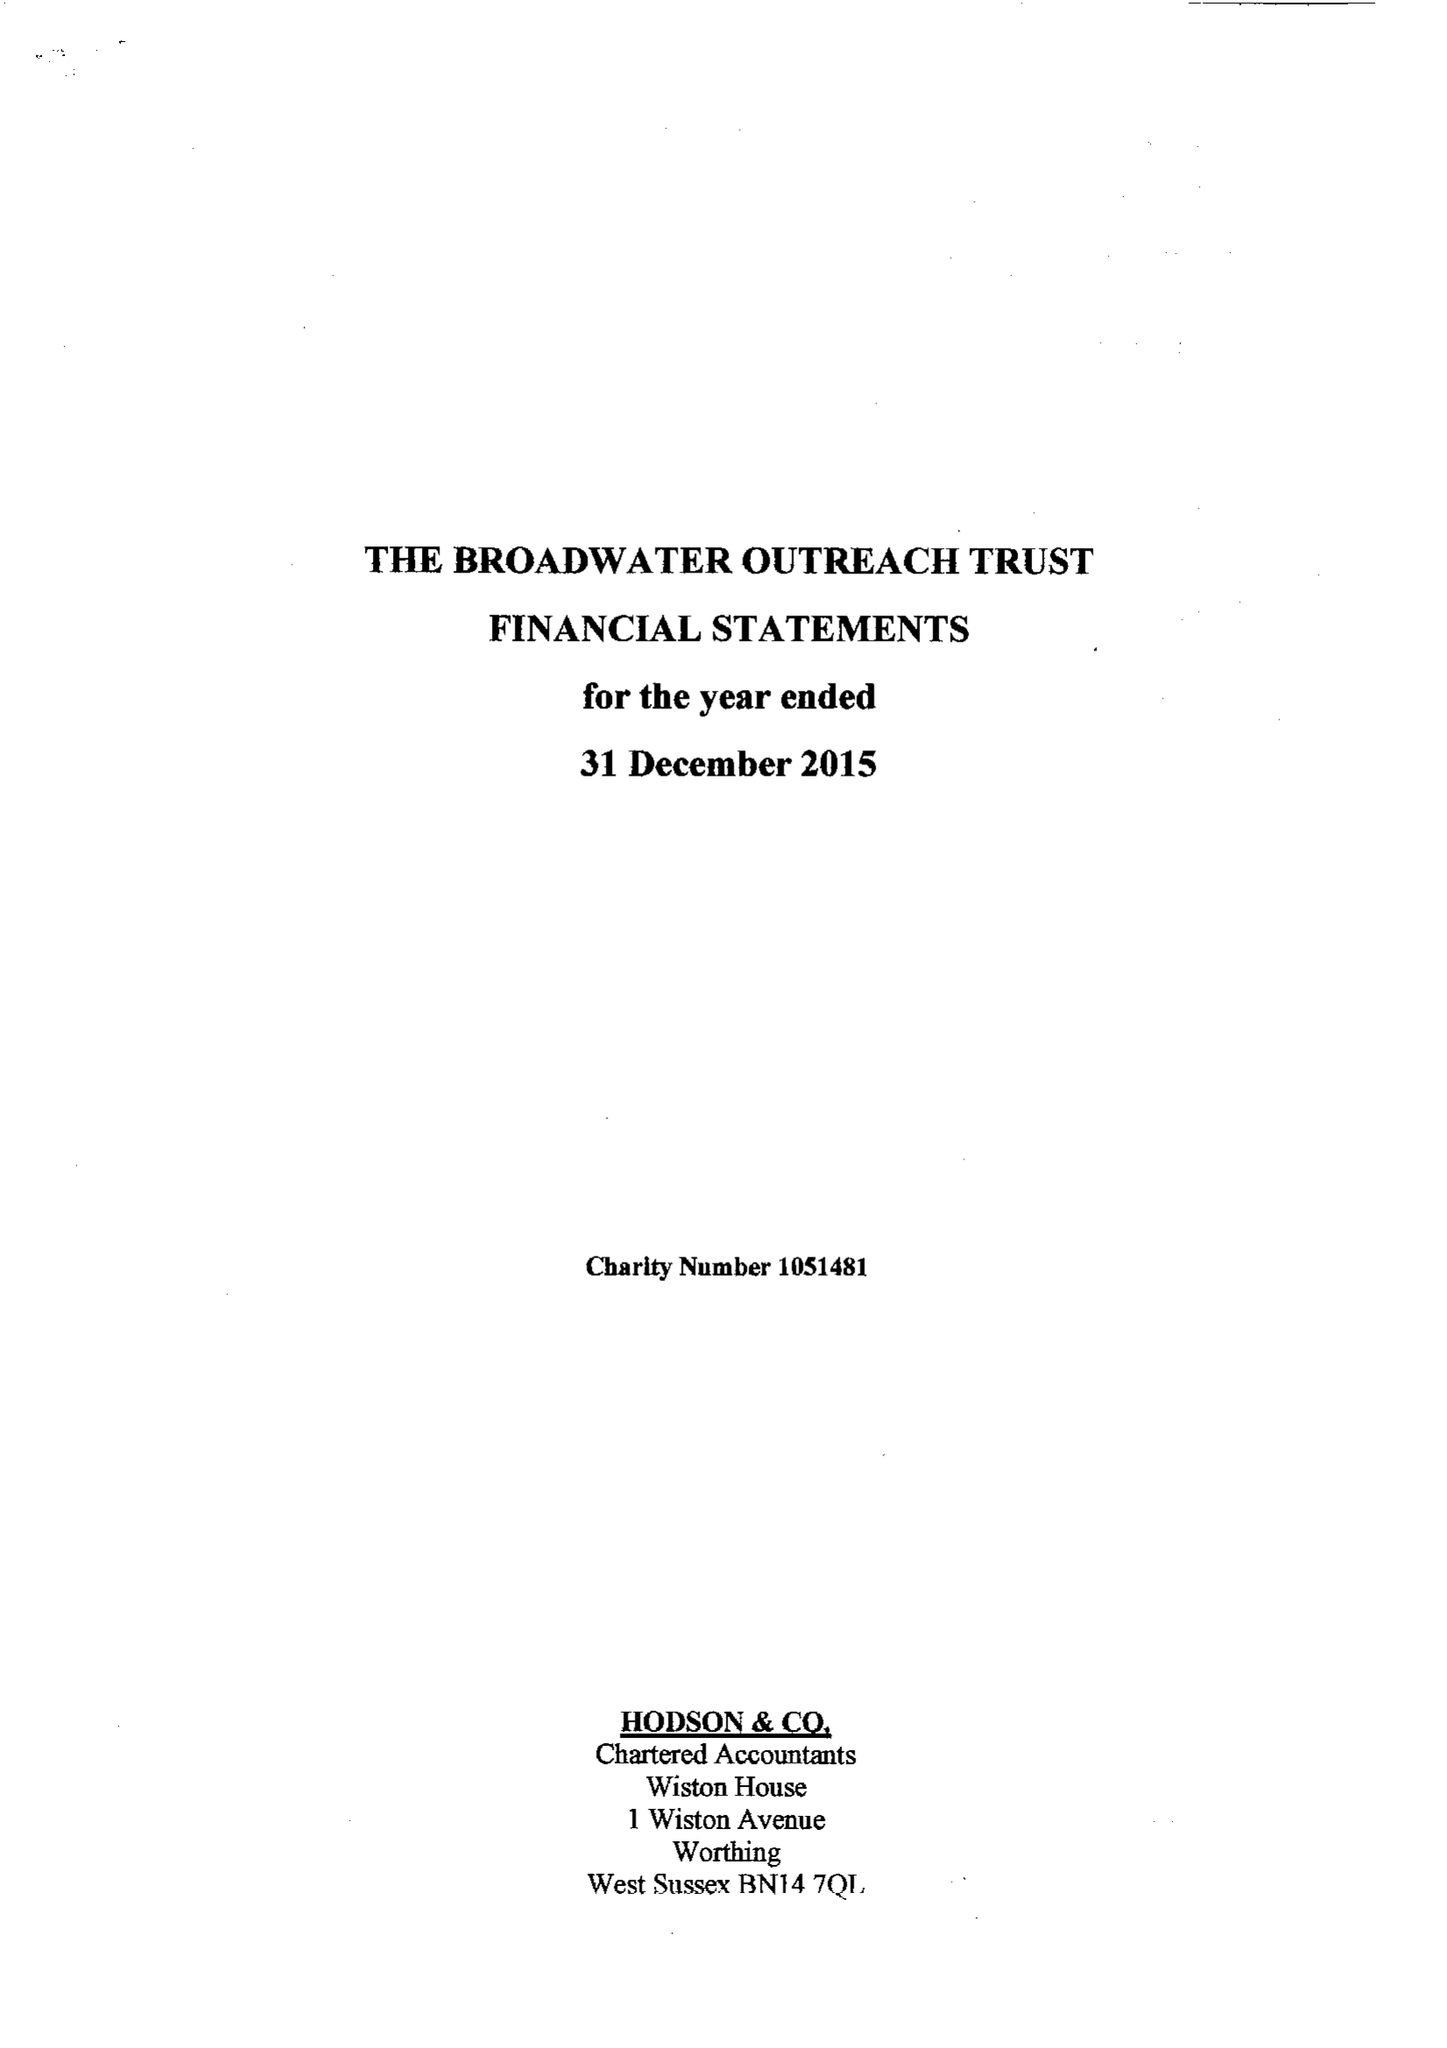What is the value for the charity_number?
Answer the question using a single word or phrase. 1051481 